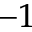Convert formula to latex. <formula><loc_0><loc_0><loc_500><loc_500>^ { - 1 }</formula> 